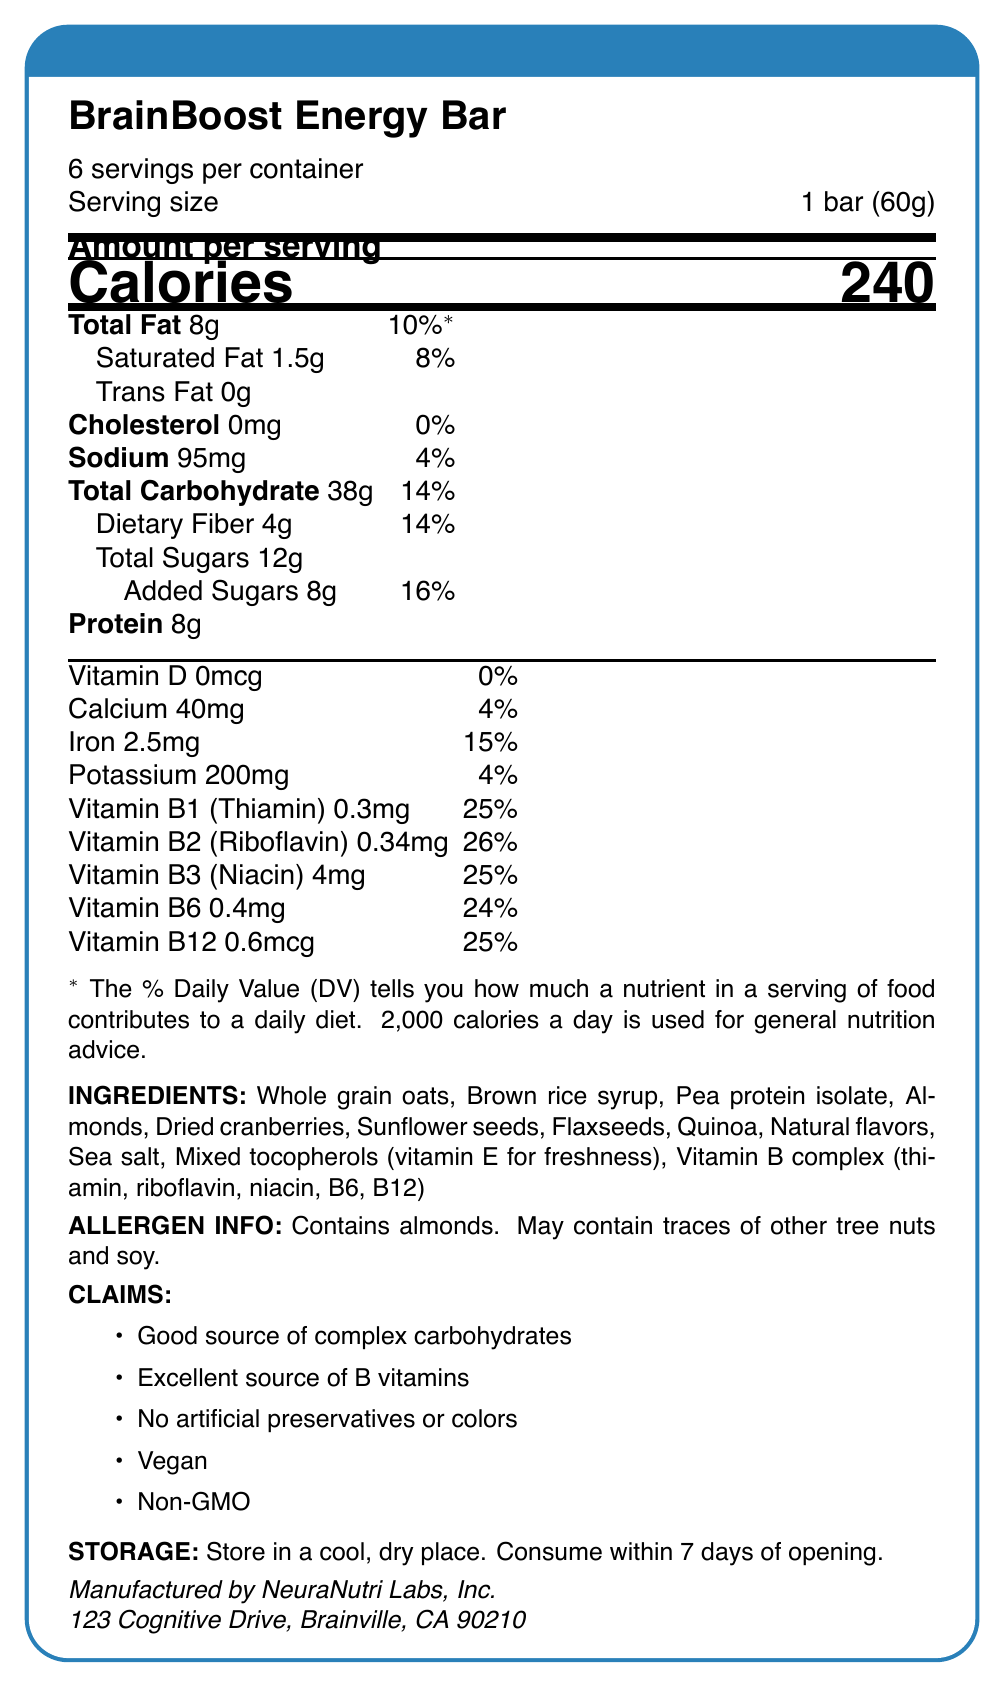how many servings are in the container? The document states "6 servings per container".
Answer: 6 what is the serving size in grams? The document specifies the serving size as "1 bar (60g)".
Answer: 60 grams how many calories are in one serving? The document shows in large text "Calories 240".
Answer: 240 what are the total sugars in one serving? According to the document, the total sugars per serving are 12 grams.
Answer: 12g what is the daily value percentage for total carbohydrates in one serving? The document lists the daily value percentage for total carbohydrates as 14%.
Answer: 14% what is the main ingredient in the BrainBoost Energy Bar? The ingredients section lists "Whole grain oats" first, making it the main ingredient.
Answer: Whole grain oats which of the following vitamins has the highest daily value percentage? A. Vitamin B1 B. Vitamin B2 C. Vitamin B6 D. Vitamin B12 The document states that Vitamin B2 (Riboflavin) has a daily value percentage of 26%, which is the highest among the listed options.
Answer: B what is the amount of cholesterol in one serving? A. 0mg B. 5mg C. 10mg D. 15mg E. 20mg The document lists the cholesterol amount as "0mg".
Answer: A does the product contain any artificial preservatives or colors? The document claims that there are "No artificial preservatives or colors".
Answer: No describe the main idea of the Nutrition Facts document for the BrainBoost Energy Bar. The document provides a comprehensive overview of the nutritional content and other relevant details of the BrainBoost Energy Bar, helping consumers make informed dietary choices.
Answer: The main idea of the document is to provide detailed nutritional information for the BrainBoost Energy Bar, including serving size, calories, macronutrients, vitamins, ingredients, allergen information, product claims, and storage instructions. what other tree nuts might the product contain traces of? The document states that the product "May contain traces of other tree nuts and soy" but does not specify which other tree nuts might be present.
Answer: Not enough information 